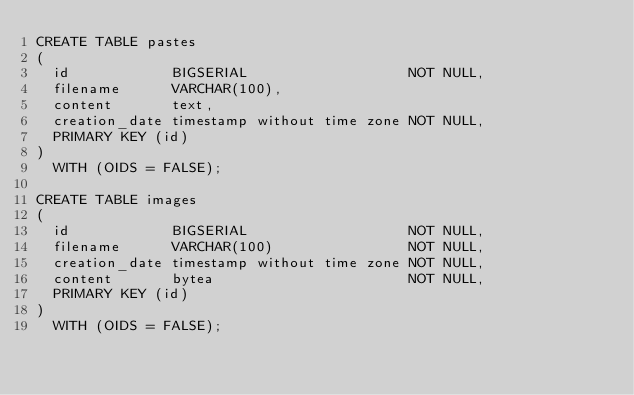<code> <loc_0><loc_0><loc_500><loc_500><_SQL_>CREATE TABLE pastes
(
  id            BIGSERIAL                   NOT NULL,
  filename      VARCHAR(100),
  content       text,
  creation_date timestamp without time zone NOT NULL,
  PRIMARY KEY (id)
)
  WITH (OIDS = FALSE);

CREATE TABLE images
(
  id            BIGSERIAL                   NOT NULL,
  filename      VARCHAR(100)                NOT NULL,
  creation_date timestamp without time zone NOT NULL,
  content       bytea                       NOT NULL,
  PRIMARY KEY (id)
)
  WITH (OIDS = FALSE);
</code> 